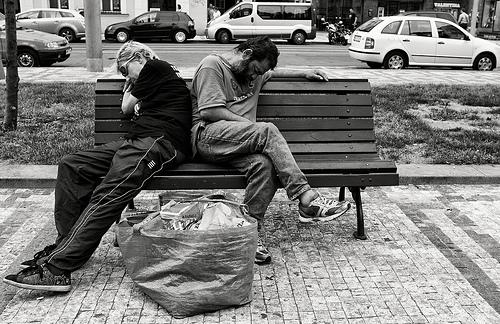What types of vehicles are present on the street in the image? There is a van, a small white car, a motorcycle, and some other cars on the street. What is between the two men sitting on the bench? There is a bag between the two men sitting on the bench. Identify the type of footwear that a man in the image is wearing. A man is wearing tennis shoes in the image. What is notable about the sidewalk and its composition? The sidewalk is made of bricks, and some individual bricks are highlighted within the image. How many people are sleeping on the bench and what are their hair colors? There are two people sleeping on the bench, one with blonde hair and one with dark hair. What type of background and objects are in the image? The image has a sidewalk made of bricks, a bench with two men sitting, a bag on the ground, and a few cars on the road. Explain the state of the grass in the image. The grass in the image is short and well-maintained. What is the main activity that the people in the image are engaging in? The main activity is that the two men are asleep and sitting on a bench. Describe the clothing worn by one of the men sitting on the bench. One man is wearing striped pants and a black shirt. What color scheme is used in the photo and how does it affect its overall appearance? The photo is in black and white, which gives it a classic and timeless appearance. Does the man with long hair have glasses on? No, it's not mentioned in the image. Is the man with red hair sitting on the left side of the bench? There are two men in the image with different hair colors, but none of them have red hair. One man has blonde hair, and the other man has dark hair. Can you see a blue car parked on the street? There are several cars on the street, but the color of the cars is not accurately described. The image is in black and white, so it's impossible to determine the color of the cars. Is there a bicycle parked near the store? There's information about a person walking in front of a store, and a motorcycle parked on the side of the road, but there's no mention of a bicycle. The instruction is misleading without any details of a bicycle in the image. Can you see a cat sleeping on the bench next to the men? The image has two men sleeping on the bench, but there's no mention of a cat or any other animal in the image. This instruction is misleading, as it's asking to identify an object that doesn't exist in the provided image. Is there a green patch of grass beside the bench? The image has information about the grass, but it doesn't contain any information about the color of the grass. The photo is in black and white, so it's impossible to identify the color green in it. 